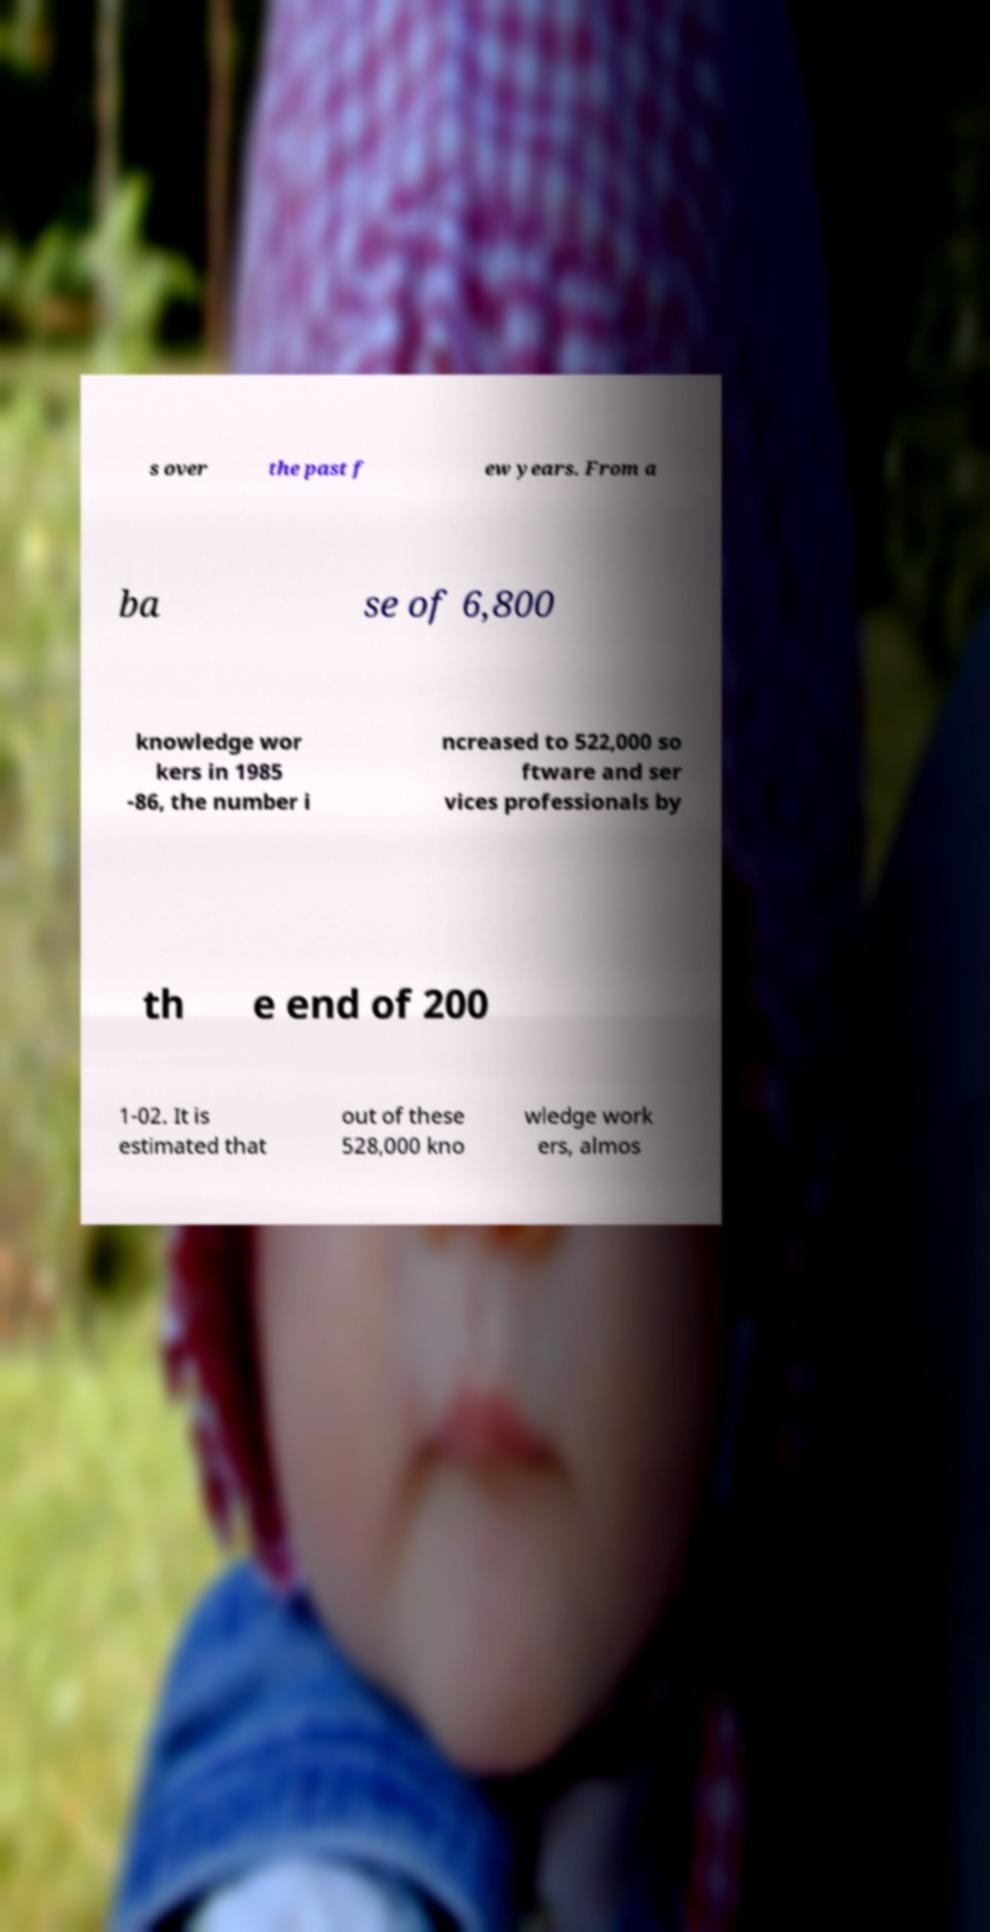Could you extract and type out the text from this image? s over the past f ew years. From a ba se of 6,800 knowledge wor kers in 1985 -86, the number i ncreased to 522,000 so ftware and ser vices professionals by th e end of 200 1-02. It is estimated that out of these 528,000 kno wledge work ers, almos 